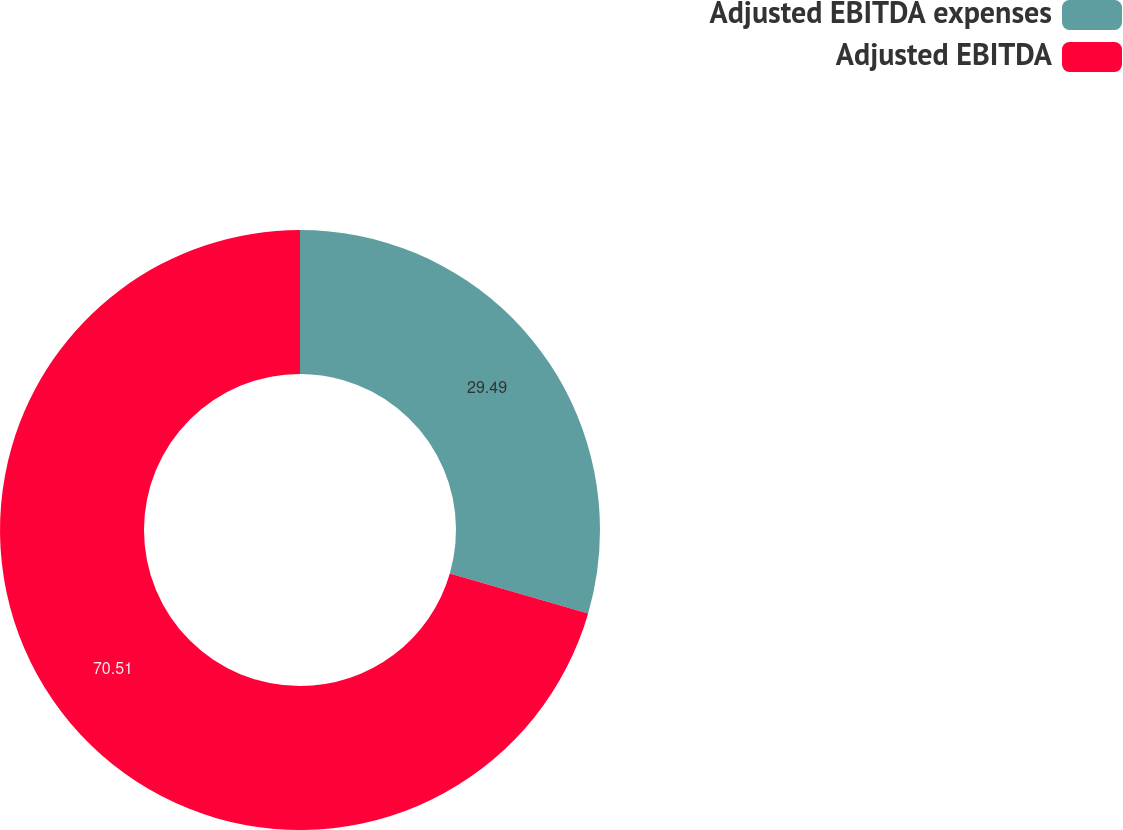<chart> <loc_0><loc_0><loc_500><loc_500><pie_chart><fcel>Adjusted EBITDA expenses<fcel>Adjusted EBITDA<nl><fcel>29.49%<fcel>70.51%<nl></chart> 